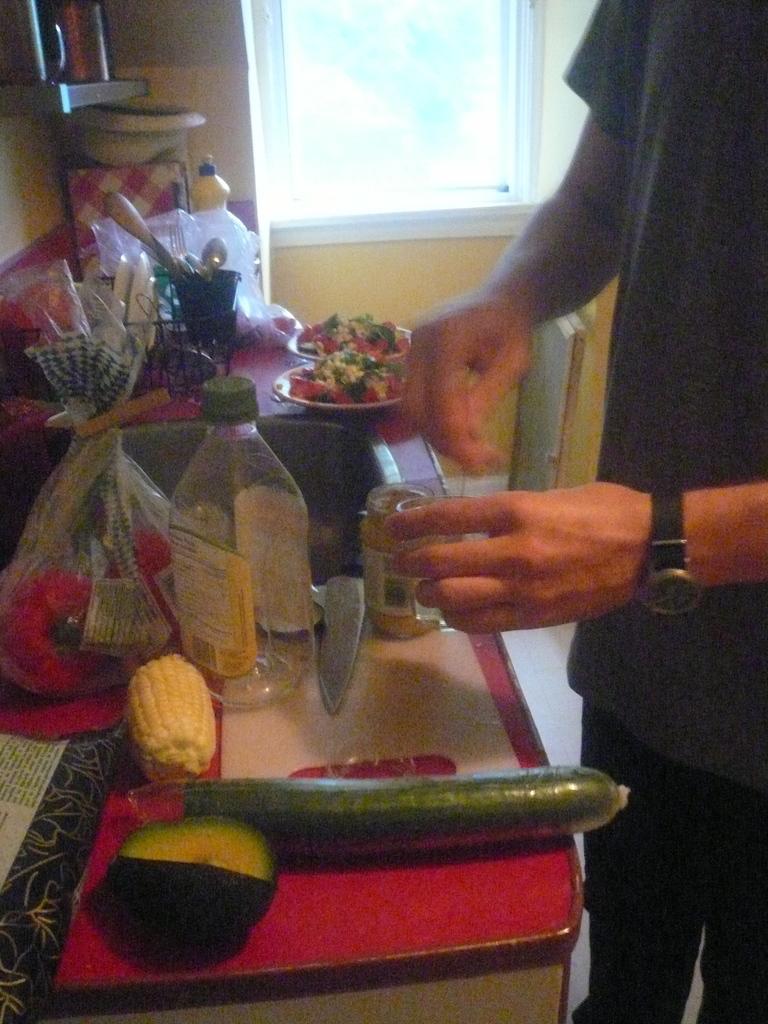Describe this image in one or two sentences. In the picture I can see a man standing on the floor, though his face is not visible and he is holding a glass in his left hand. I can see the vegetables, storage can, plates and other kitchen accessories are kept on the table. I can see the glass window at the top of the picture. 